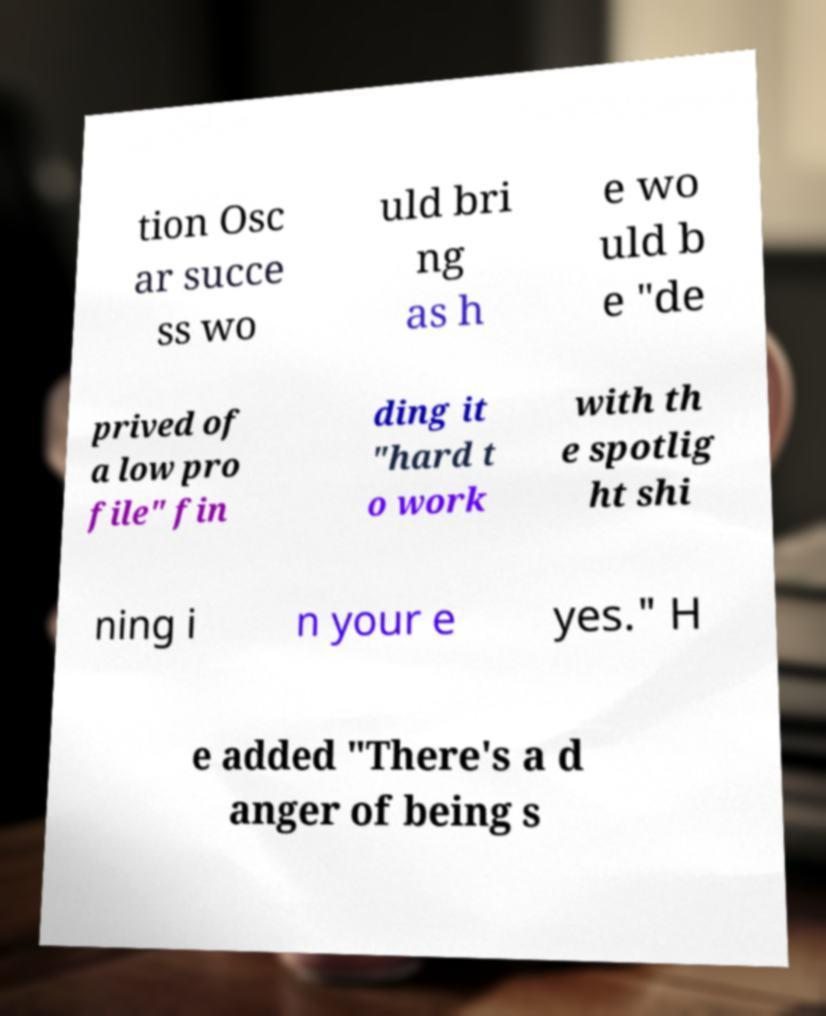Could you extract and type out the text from this image? tion Osc ar succe ss wo uld bri ng as h e wo uld b e "de prived of a low pro file" fin ding it "hard t o work with th e spotlig ht shi ning i n your e yes." H e added "There's a d anger of being s 